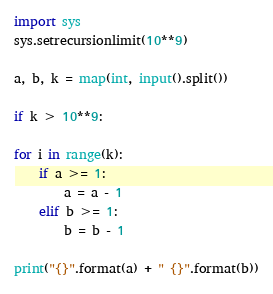Convert code to text. <code><loc_0><loc_0><loc_500><loc_500><_Python_>import sys
sys.setrecursionlimit(10**9)

a, b, k = map(int, input().split())

if k > 10**9:

for i in range(k):
    if a >= 1:
        a = a - 1
    elif b >= 1:
        b = b - 1

print("{}".format(a) + " {}".format(b))
</code> 